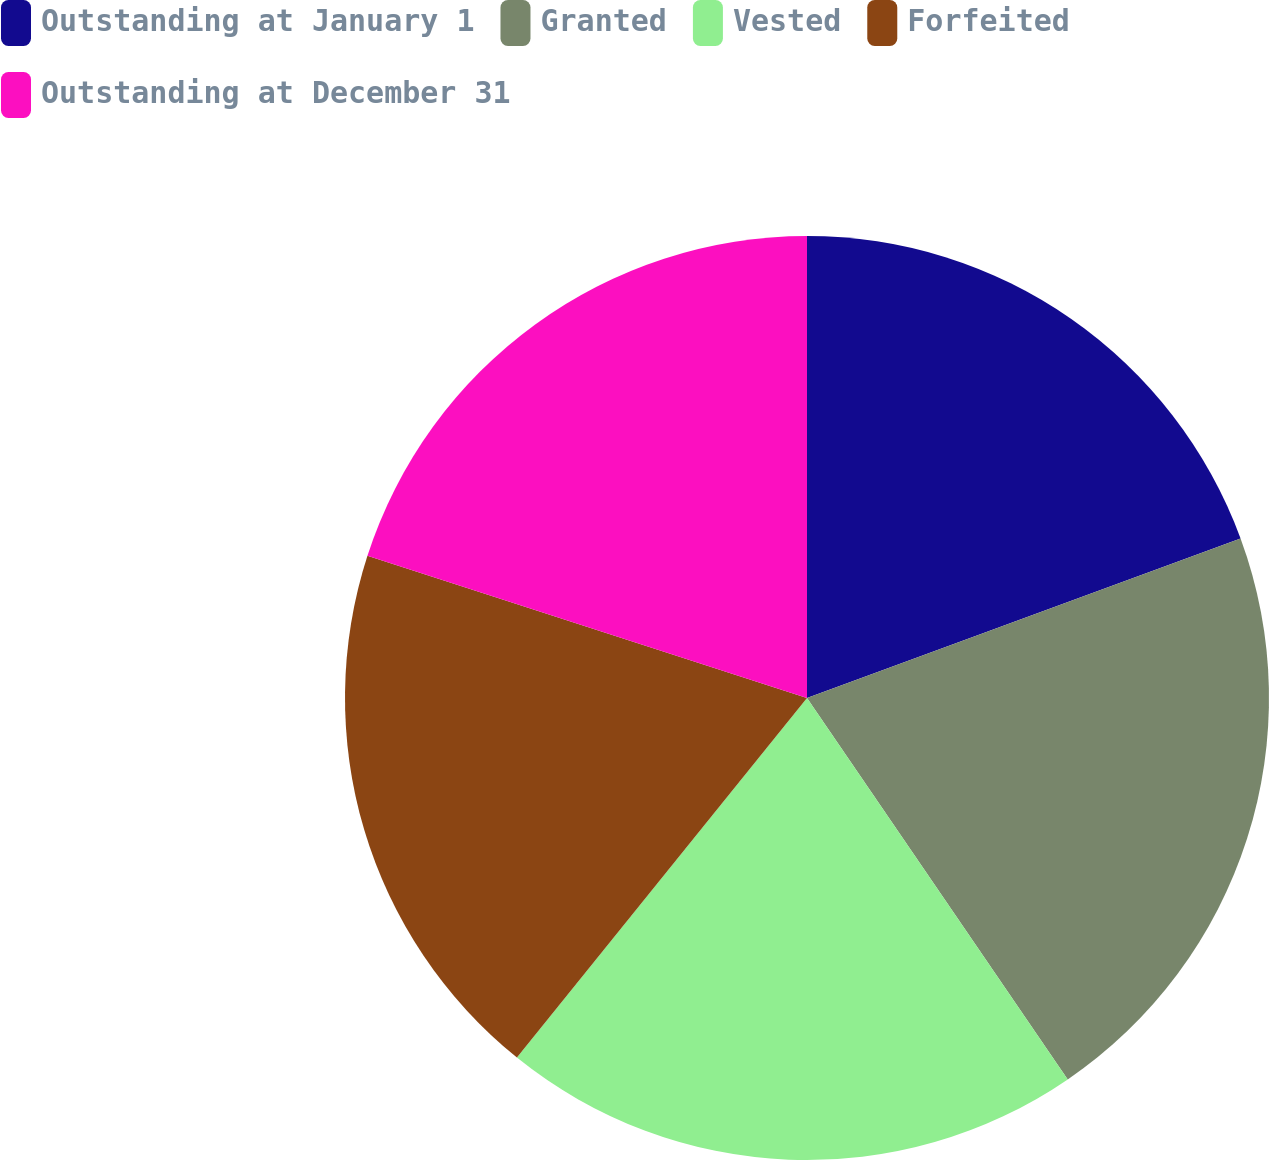<chart> <loc_0><loc_0><loc_500><loc_500><pie_chart><fcel>Outstanding at January 1<fcel>Granted<fcel>Vested<fcel>Forfeited<fcel>Outstanding at December 31<nl><fcel>19.39%<fcel>21.07%<fcel>20.35%<fcel>19.18%<fcel>20.02%<nl></chart> 